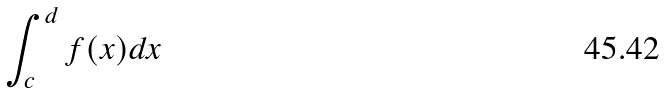<formula> <loc_0><loc_0><loc_500><loc_500>\int _ { c } ^ { d } f ( x ) d x</formula> 